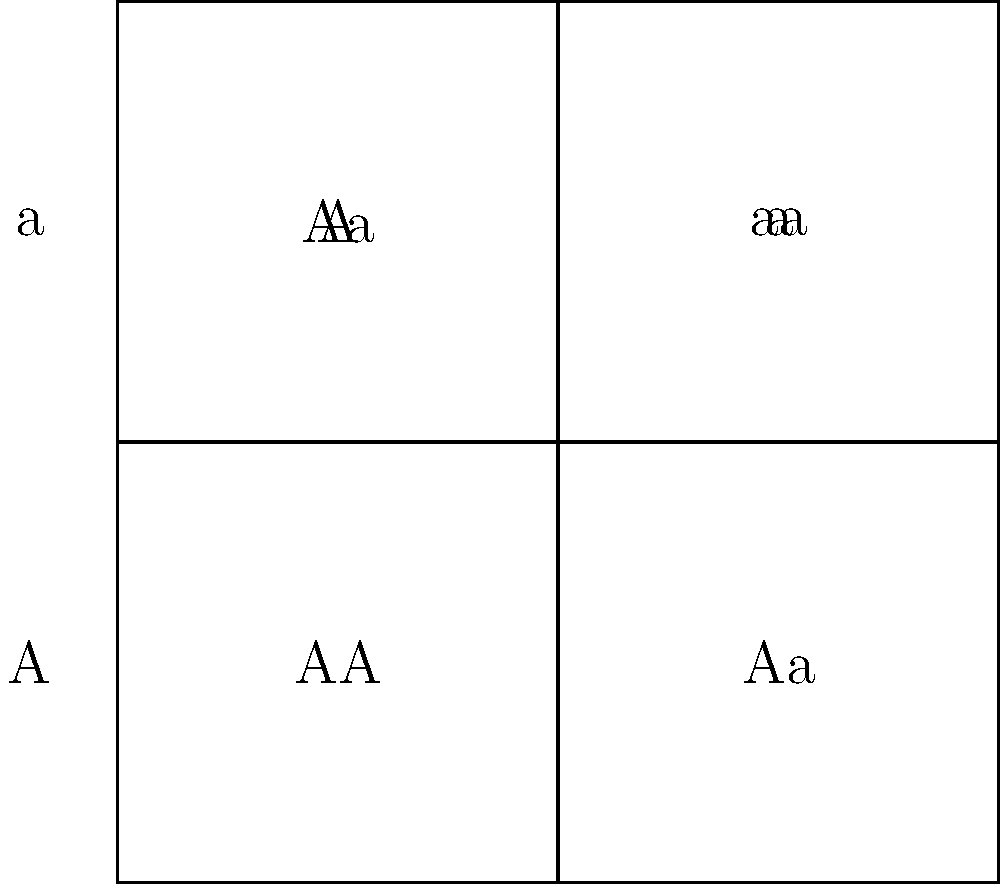In a family where both parents are carriers for a recessive genetic disorder, what is the probability that their child will be affected by the disorder? Use the Punnett square provided to support your answer. To solve this problem, we need to follow these steps:

1. Identify the genotypes of the parents:
   Both parents are carriers, so they have the genotype Aa, where:
   A = dominant allele (unaffected)
   a = recessive allele (affected)

2. Analyze the Punnett square:
   - The Punnett square shows all possible genetic combinations from the parents.
   - The genotypes of the offspring are: AA, Aa, Aa, and aa.

3. Identify the affected genotype:
   - The recessive disorder is expressed only when an individual has two copies of the recessive allele (aa).

4. Calculate the probability:
   - Out of the four possible outcomes, only one results in the affected genotype (aa).
   - Probability = (Number of favorable outcomes) / (Total number of possible outcomes)
   - Probability = 1 / 4 = 0.25 or 25%

Therefore, there is a 25% chance that the child will be affected by the recessive genetic disorder.
Answer: 25% 